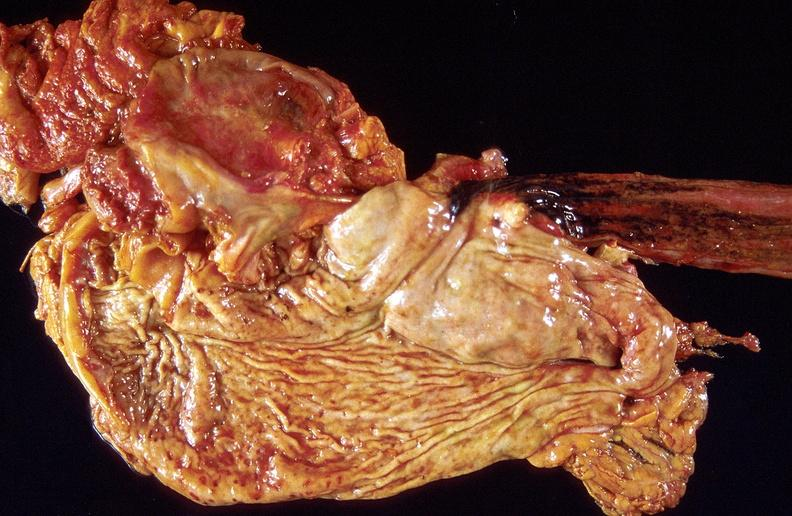where does this belong to?
Answer the question using a single word or phrase. Gastrointestinal system 